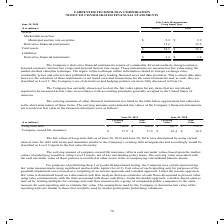According to Carpenter Technology's financial document, What is the carrying value of long-term debt in 2019? According to the financial document, $550.6 (in millions). The relevant text states: "Value Carrying Value Fair Value Long-term debt $ 550.6 $ 560.6 $ 545.7 $ 558.3 Company-owned life insurance $ 17.9 $ 17.9 $ 16.4 $ 16.4..." Also, What is the fair value of long-term debt in 2018? According to the financial document, $558.3 (in millions). The relevant text states: "ir Value Long-term debt $ 550.6 $ 560.6 $ 545.7 $ 558.3 Company-owned life insurance $ 17.9 $ 17.9 $ 16.4 $ 16.4..." Also, In which years is the carrying and fair values of long-term debt provided? The document shows two values: 2019 and 2018. From the document: "June 30, 2019 June 30, 2018 June 30, 2019 June 30, 2018..." Additionally, In which year was the fair value of Company-owned life insurance larger? According to the financial document, 2019. The relevant text states: "June 30, 2019 June 30, 2018..." Also, can you calculate: What was the change in the fair value of Company-owned life insurance in 2019 from 2018? Based on the calculation: 17.9-16.4, the result is 1.5 (in millions). This is based on the information: "58.3 Company-owned life insurance $ 17.9 $ 17.9 $ 16.4 $ 16.4 .6 $ 545.7 $ 558.3 Company-owned life insurance $ 17.9 $ 17.9 $ 16.4 $ 16.4..." The key data points involved are: 16.4, 17.9. Also, can you calculate: What was the percentage change in the fair value of Company-owned life insurance in 2019 from 2018? To answer this question, I need to perform calculations using the financial data. The calculation is: (17.9-16.4)/16.4, which equals 9.15 (percentage). This is based on the information: "58.3 Company-owned life insurance $ 17.9 $ 17.9 $ 16.4 $ 16.4 .6 $ 545.7 $ 558.3 Company-owned life insurance $ 17.9 $ 17.9 $ 16.4 $ 16.4..." The key data points involved are: 16.4, 17.9. 